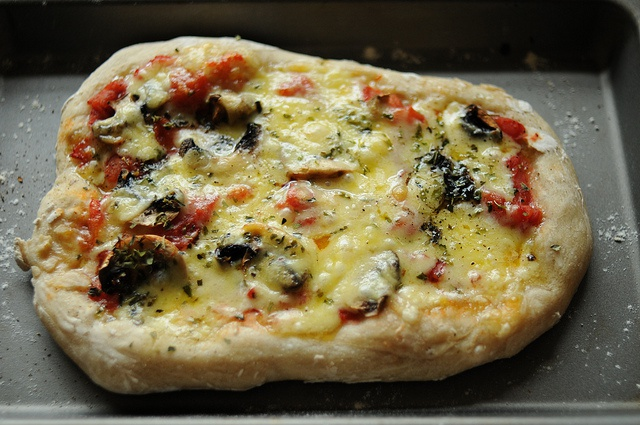Describe the objects in this image and their specific colors. I can see a pizza in black, tan, beige, and olive tones in this image. 